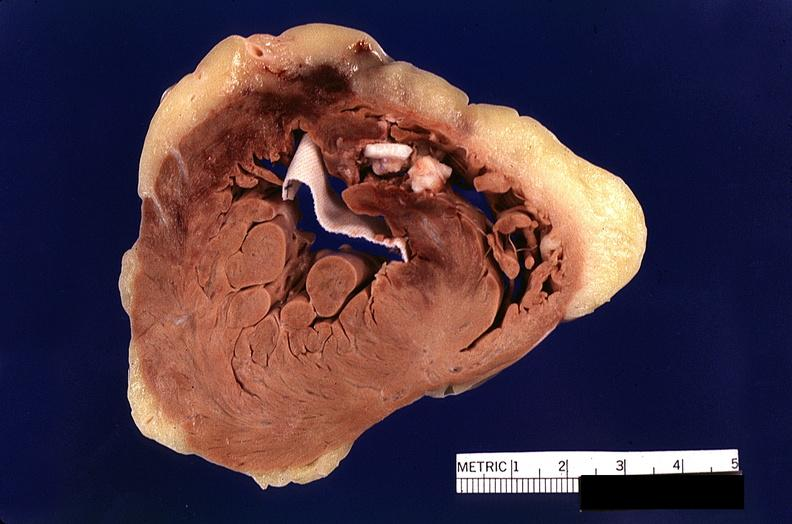what is present?
Answer the question using a single word or phrase. Cardiovascular 